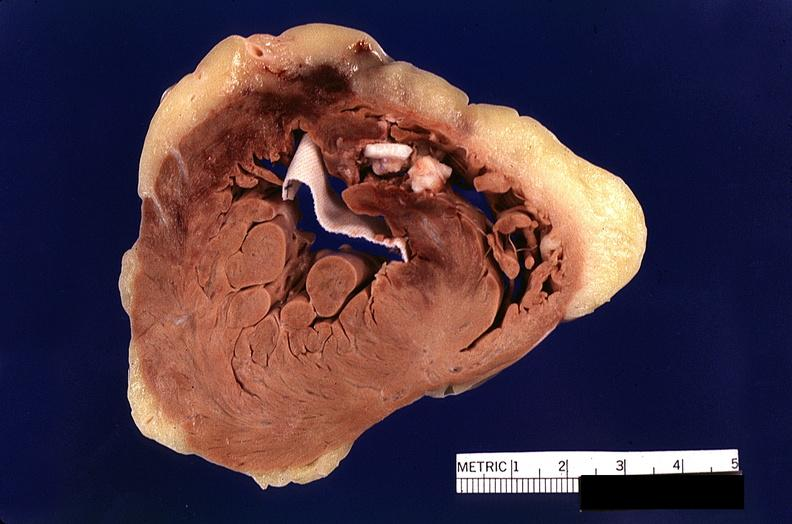what is present?
Answer the question using a single word or phrase. Cardiovascular 